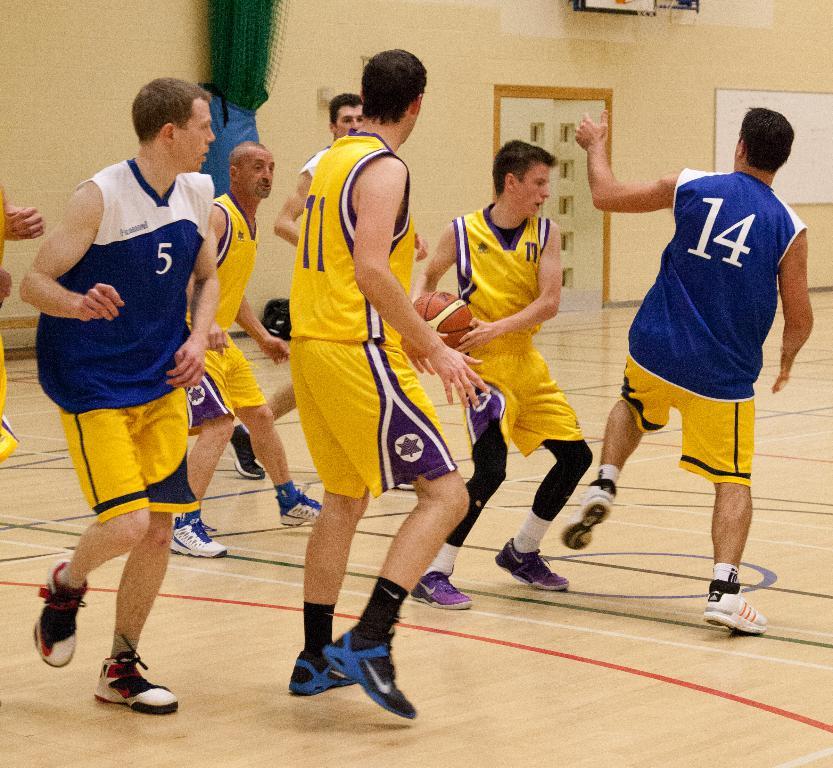What number is on the blue jersey to the right?
Offer a terse response. 14. 